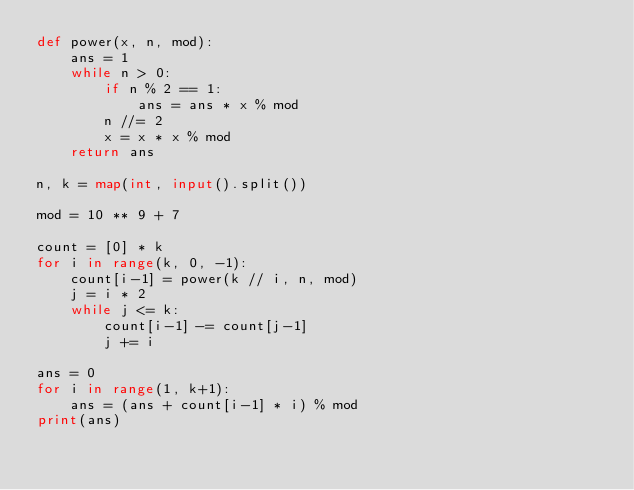<code> <loc_0><loc_0><loc_500><loc_500><_Python_>def power(x, n, mod):
    ans = 1
    while n > 0:
        if n % 2 == 1:
            ans = ans * x % mod
        n //= 2
        x = x * x % mod
    return ans

n, k = map(int, input().split())

mod = 10 ** 9 + 7

count = [0] * k
for i in range(k, 0, -1):
    count[i-1] = power(k // i, n, mod)
    j = i * 2
    while j <= k:
        count[i-1] -= count[j-1]
        j += i

ans = 0
for i in range(1, k+1):
    ans = (ans + count[i-1] * i) % mod
print(ans)
</code> 